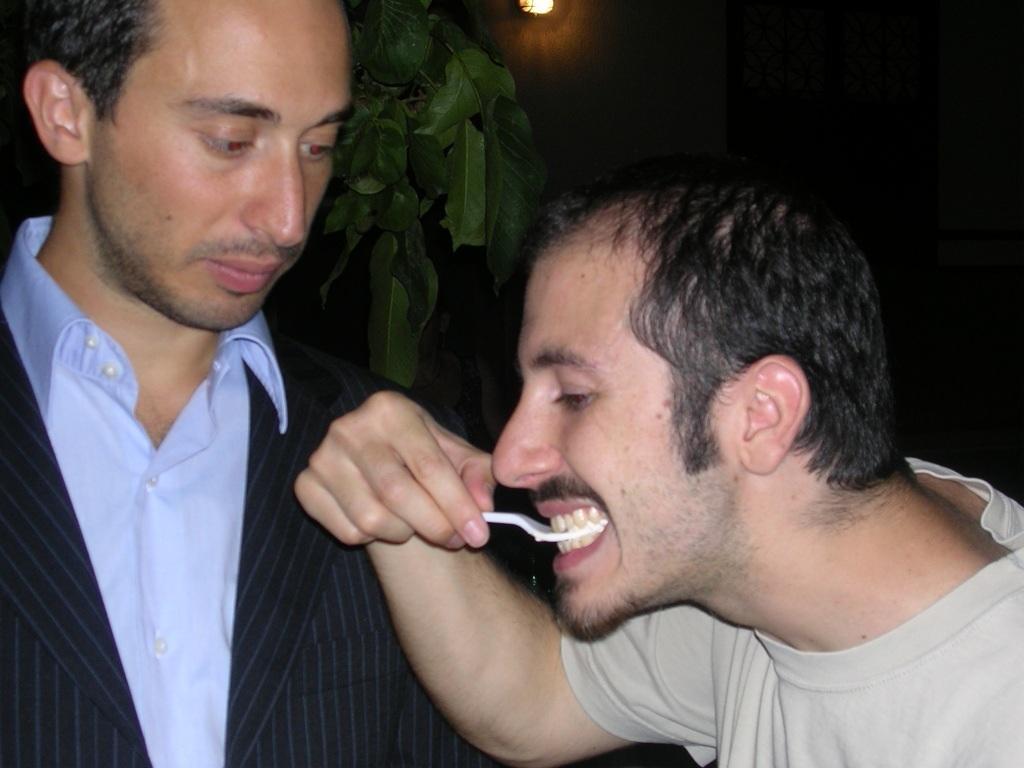Can you describe this image briefly? In the image we can see there are people standing and a man is holding spoon in his mouth. Behind there is a plant. 